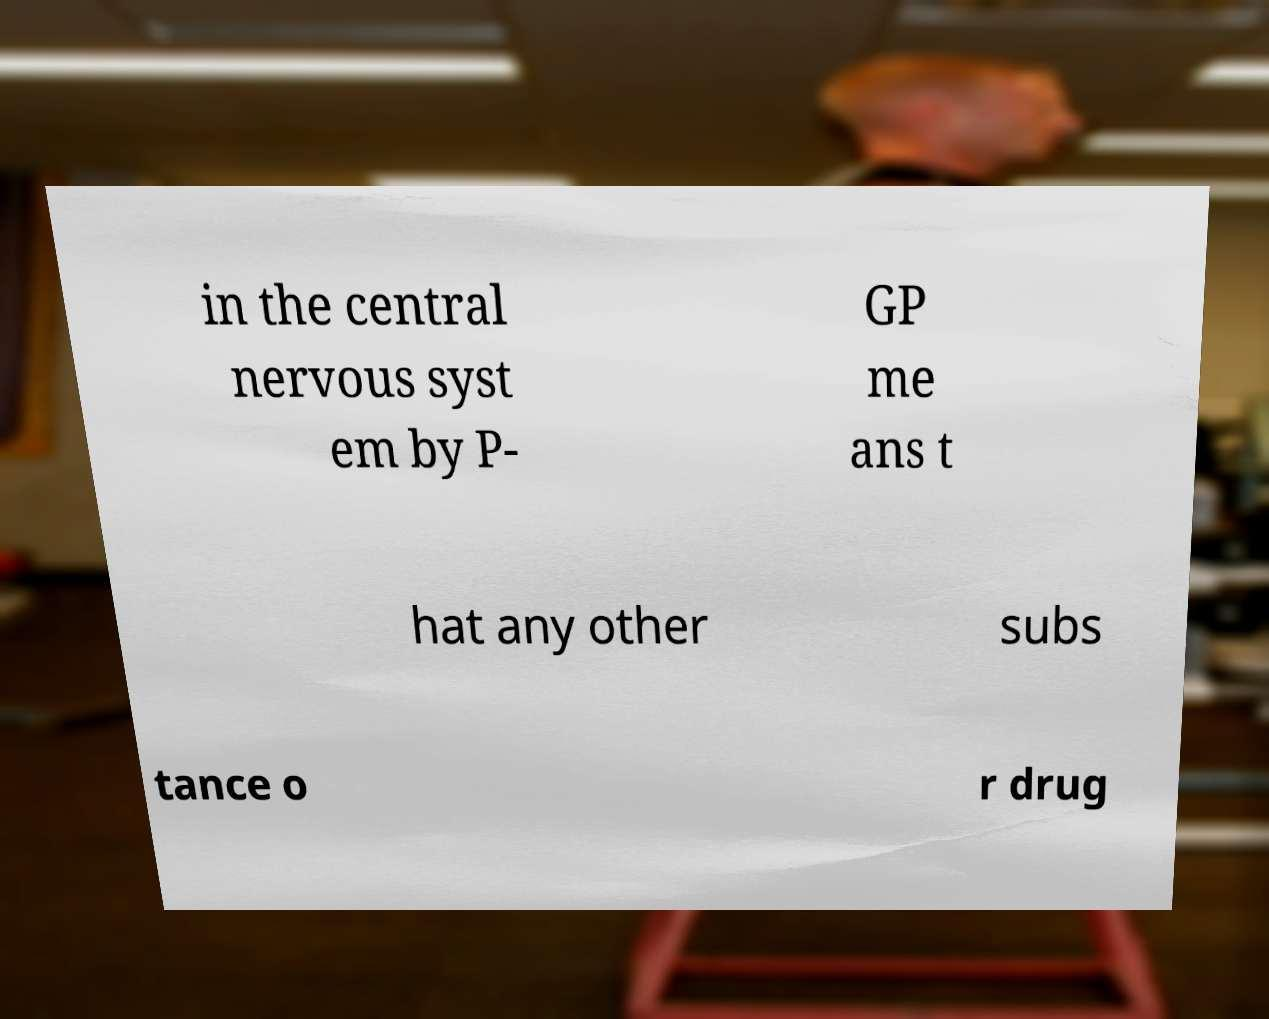Could you extract and type out the text from this image? in the central nervous syst em by P- GP me ans t hat any other subs tance o r drug 